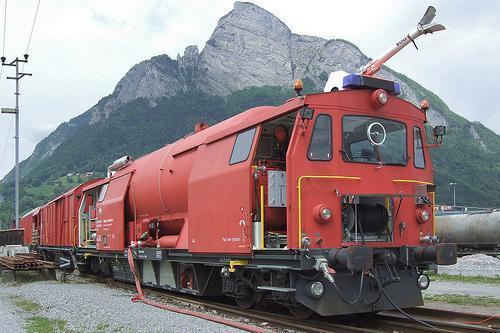How many trains are there?
Give a very brief answer. 1. 